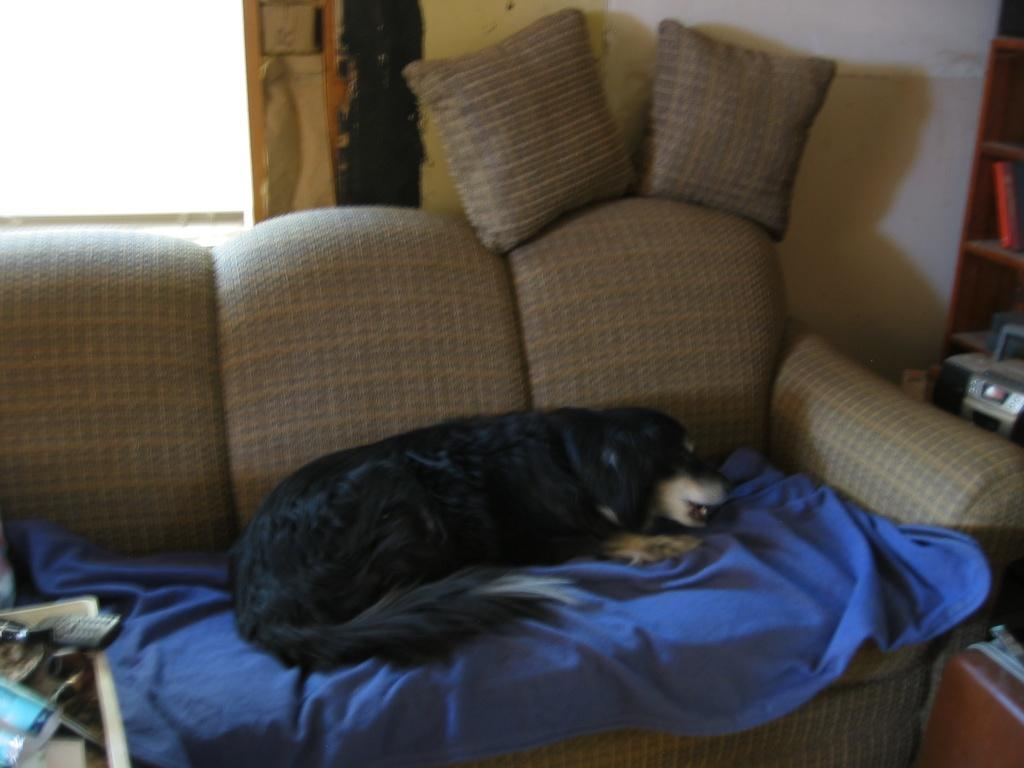What type of furniture is in the image? There is a sofa in the image. What color is the carpet on the sofa? There is a blue carpet on the sofa. What animal can be seen on the carpet? There is a black-colored dog on the carpet. How many pillows are on the sofa? There are two pillows on the sofa. What can be seen in the background of the image? There is a wall visible in the image. What type of chicken is being plotted against in the image? There is no chicken or plot present in the image. 